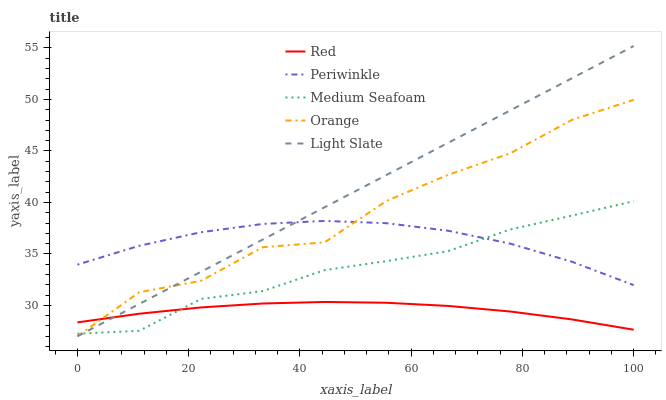Does Red have the minimum area under the curve?
Answer yes or no. Yes. Does Light Slate have the maximum area under the curve?
Answer yes or no. Yes. Does Periwinkle have the minimum area under the curve?
Answer yes or no. No. Does Periwinkle have the maximum area under the curve?
Answer yes or no. No. Is Light Slate the smoothest?
Answer yes or no. Yes. Is Orange the roughest?
Answer yes or no. Yes. Is Periwinkle the smoothest?
Answer yes or no. No. Is Periwinkle the roughest?
Answer yes or no. No. Does Orange have the lowest value?
Answer yes or no. Yes. Does Periwinkle have the lowest value?
Answer yes or no. No. Does Light Slate have the highest value?
Answer yes or no. Yes. Does Periwinkle have the highest value?
Answer yes or no. No. Is Red less than Periwinkle?
Answer yes or no. Yes. Is Periwinkle greater than Red?
Answer yes or no. Yes. Does Periwinkle intersect Orange?
Answer yes or no. Yes. Is Periwinkle less than Orange?
Answer yes or no. No. Is Periwinkle greater than Orange?
Answer yes or no. No. Does Red intersect Periwinkle?
Answer yes or no. No. 